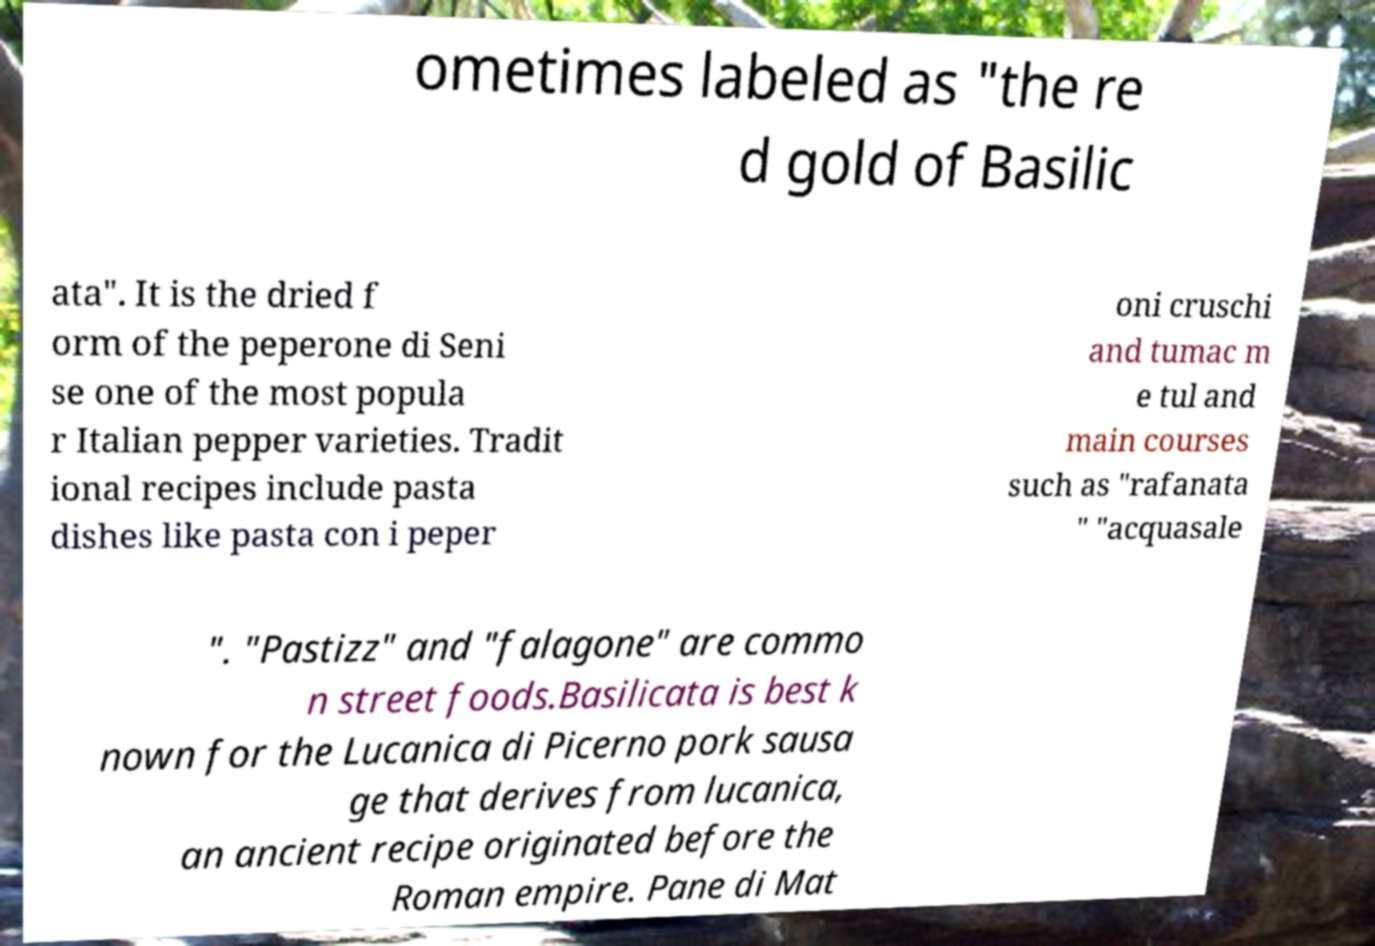Could you assist in decoding the text presented in this image and type it out clearly? ometimes labeled as "the re d gold of Basilic ata". It is the dried f orm of the peperone di Seni se one of the most popula r Italian pepper varieties. Tradit ional recipes include pasta dishes like pasta con i peper oni cruschi and tumac m e tul and main courses such as "rafanata " "acquasale ". "Pastizz" and "falagone" are commo n street foods.Basilicata is best k nown for the Lucanica di Picerno pork sausa ge that derives from lucanica, an ancient recipe originated before the Roman empire. Pane di Mat 